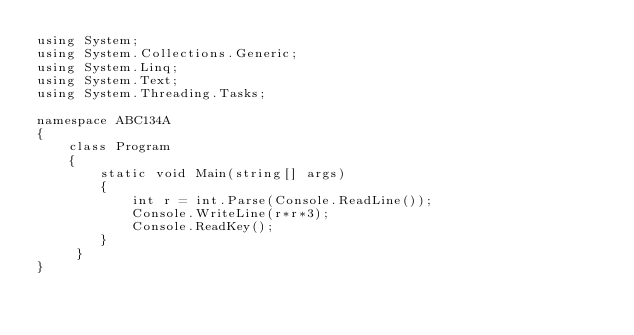Convert code to text. <code><loc_0><loc_0><loc_500><loc_500><_C#_>using System;
using System.Collections.Generic;
using System.Linq;
using System.Text;
using System.Threading.Tasks;

namespace ABC134A
{
    class Program
    {
        static void Main(string[] args)
        {
            int r = int.Parse(Console.ReadLine());
            Console.WriteLine(r*r*3);
            Console.ReadKey();
        }
     }
}
</code> 